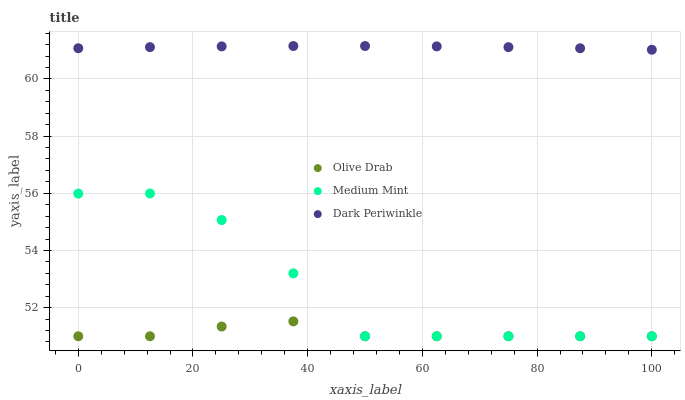Does Olive Drab have the minimum area under the curve?
Answer yes or no. Yes. Does Dark Periwinkle have the maximum area under the curve?
Answer yes or no. Yes. Does Dark Periwinkle have the minimum area under the curve?
Answer yes or no. No. Does Olive Drab have the maximum area under the curve?
Answer yes or no. No. Is Dark Periwinkle the smoothest?
Answer yes or no. Yes. Is Medium Mint the roughest?
Answer yes or no. Yes. Is Olive Drab the smoothest?
Answer yes or no. No. Is Olive Drab the roughest?
Answer yes or no. No. Does Medium Mint have the lowest value?
Answer yes or no. Yes. Does Dark Periwinkle have the lowest value?
Answer yes or no. No. Does Dark Periwinkle have the highest value?
Answer yes or no. Yes. Does Olive Drab have the highest value?
Answer yes or no. No. Is Olive Drab less than Dark Periwinkle?
Answer yes or no. Yes. Is Dark Periwinkle greater than Olive Drab?
Answer yes or no. Yes. Does Medium Mint intersect Olive Drab?
Answer yes or no. Yes. Is Medium Mint less than Olive Drab?
Answer yes or no. No. Is Medium Mint greater than Olive Drab?
Answer yes or no. No. Does Olive Drab intersect Dark Periwinkle?
Answer yes or no. No. 